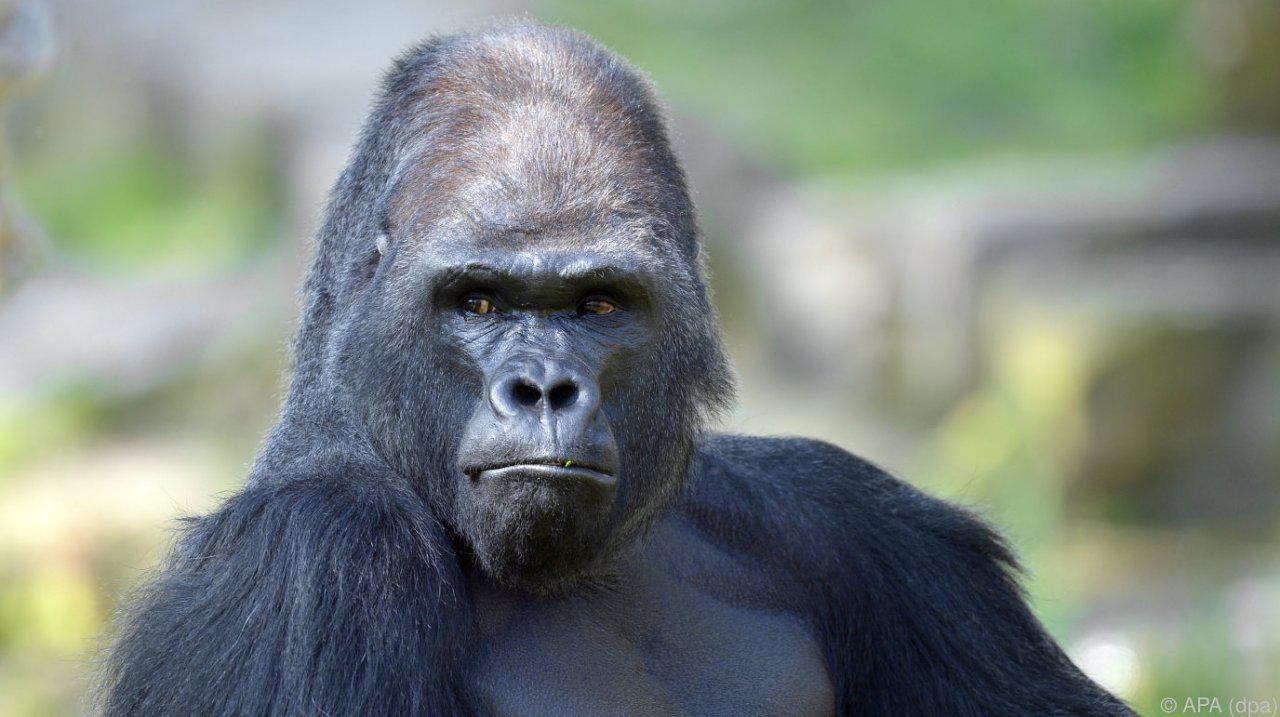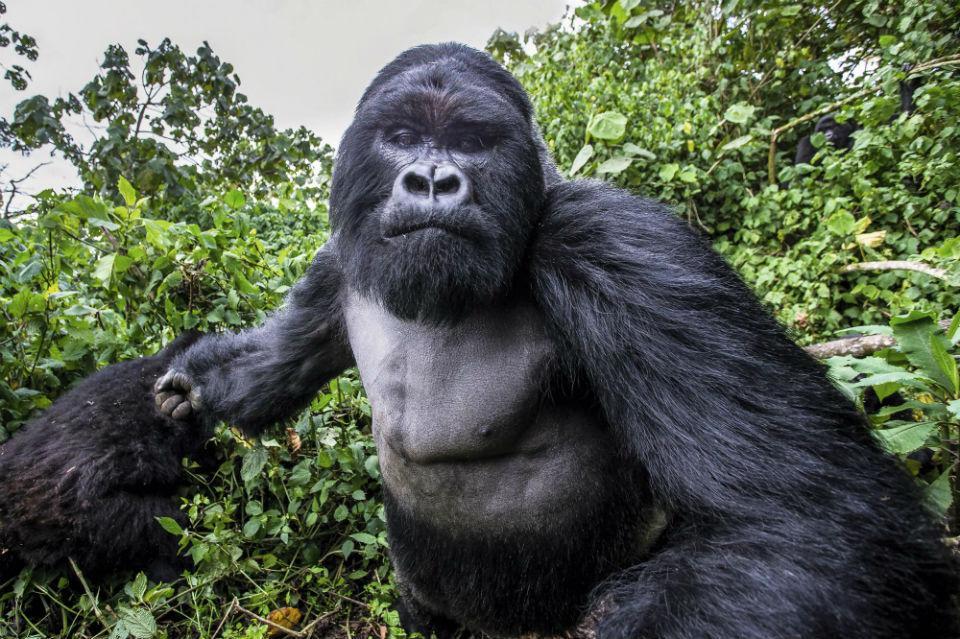The first image is the image on the left, the second image is the image on the right. For the images shown, is this caption "A concrete barrier can be seen behind the ape in the image on the left." true? Answer yes or no. No. The first image is the image on the left, the second image is the image on the right. Examine the images to the left and right. Is the description "One image shows a gorilla standing up straight, and the other shows a gorilla turning its head to eye the camera, with one elbow bent and hand near its chin." accurate? Answer yes or no. No. 